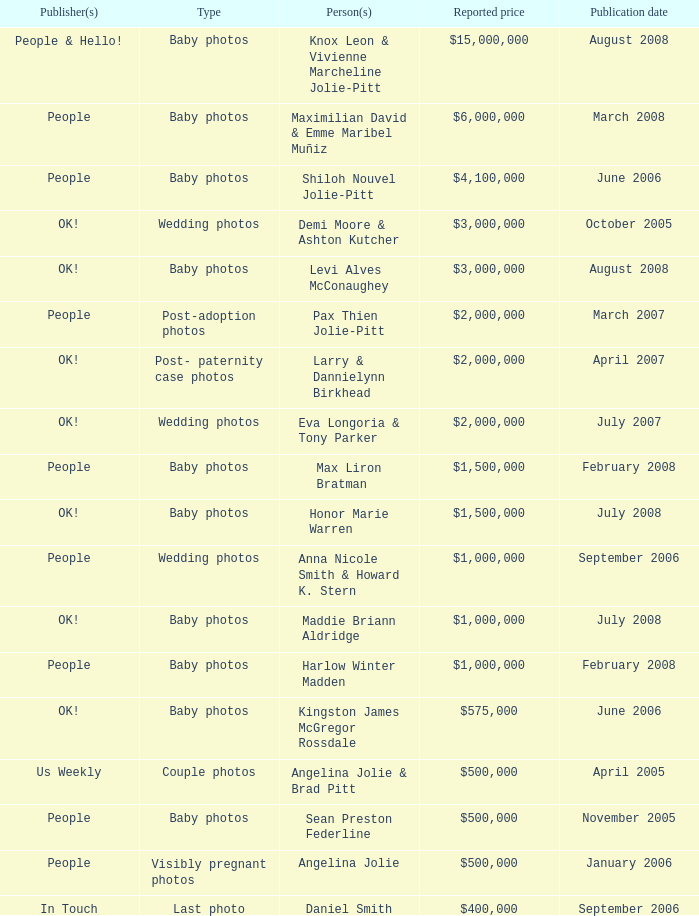What type of photos of Angelina Jolie cost $500,000? Visibly pregnant photos. 